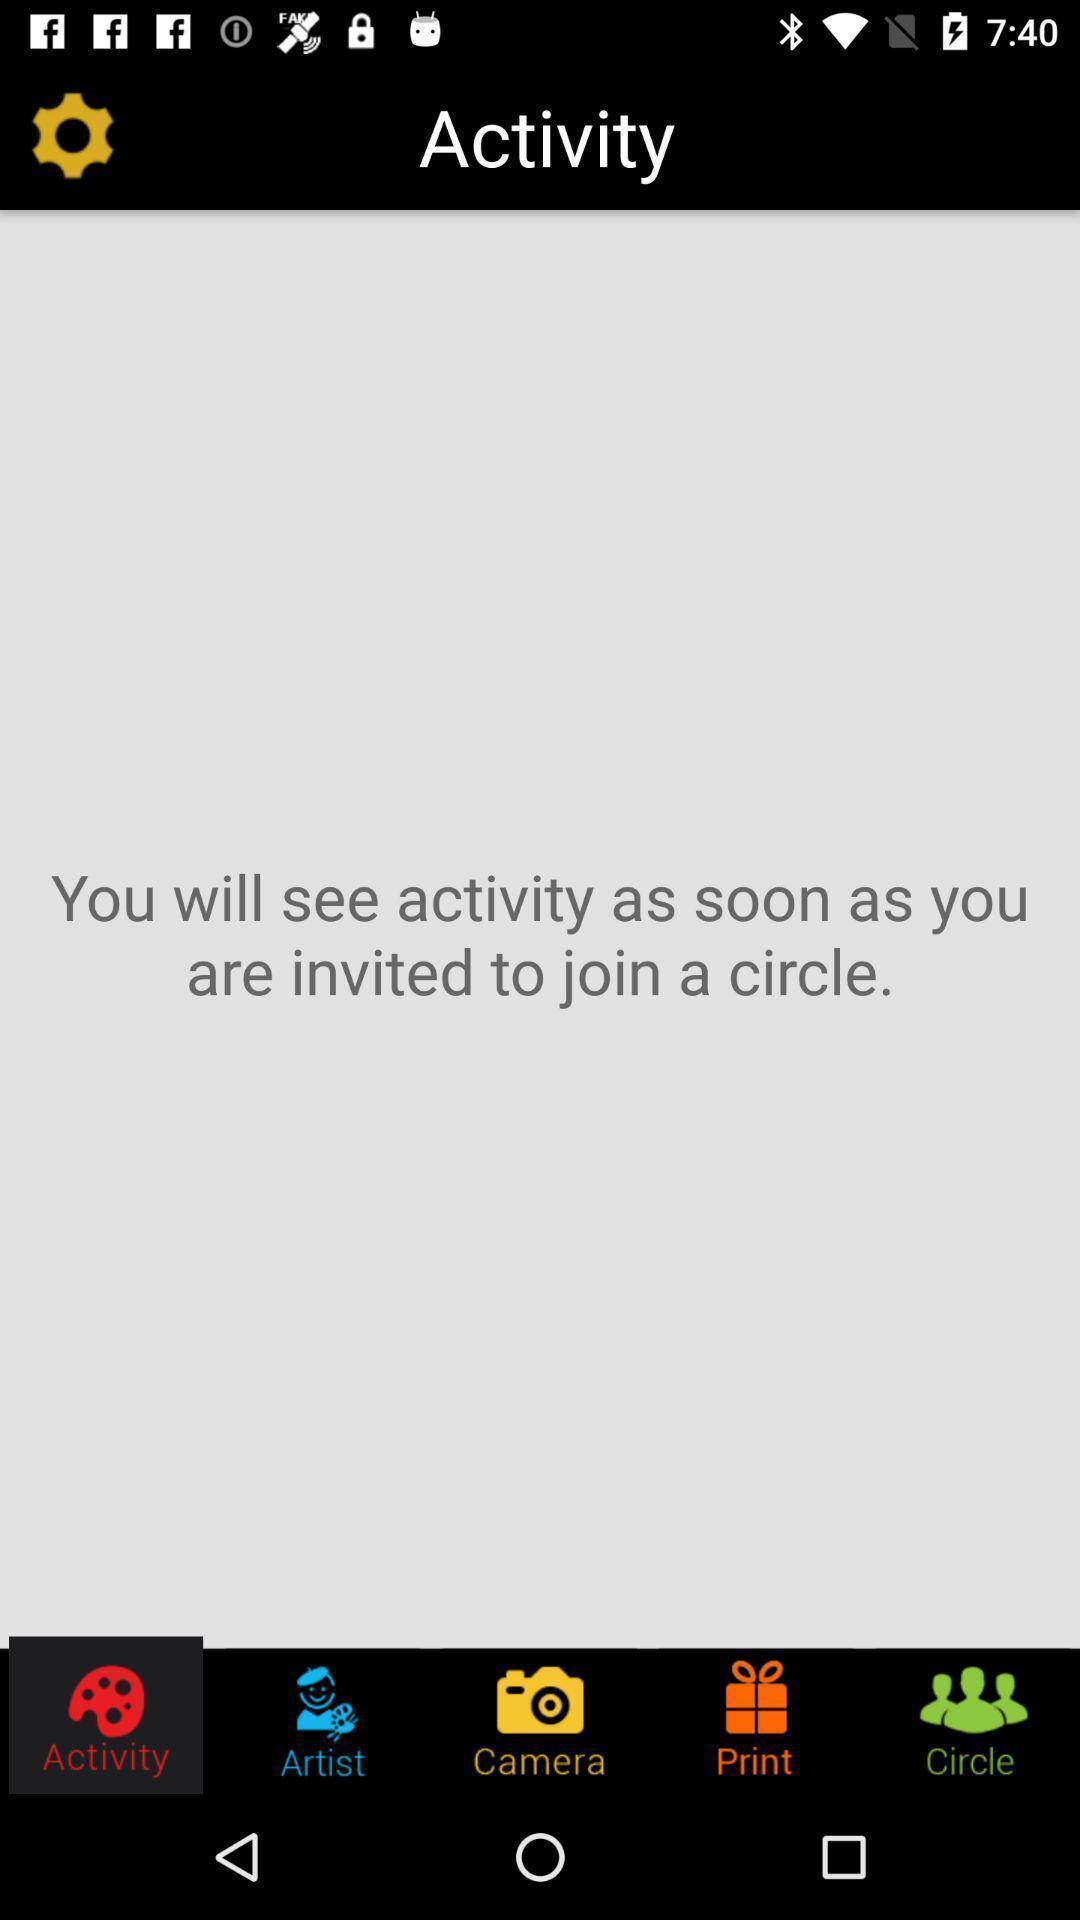Describe the key features of this screenshot. Screen displaying multiple picture editing control options. 